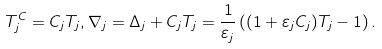<formula> <loc_0><loc_0><loc_500><loc_500>T _ { j } ^ { C } = C _ { j } T _ { j } , \nabla _ { j } = \Delta _ { j } + C _ { j } T _ { j } = \frac { 1 } { \varepsilon _ { j } } \left ( ( 1 + \varepsilon _ { j } C _ { j } ) T _ { j } - 1 \right ) .</formula> 